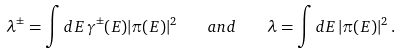Convert formula to latex. <formula><loc_0><loc_0><loc_500><loc_500>\lambda ^ { \pm } = \int d E \, \gamma ^ { \pm } ( E ) | \pi ( E ) | ^ { 2 } \quad a n d \quad \lambda = \int d E \, | \pi ( E ) | ^ { 2 } \, .</formula> 